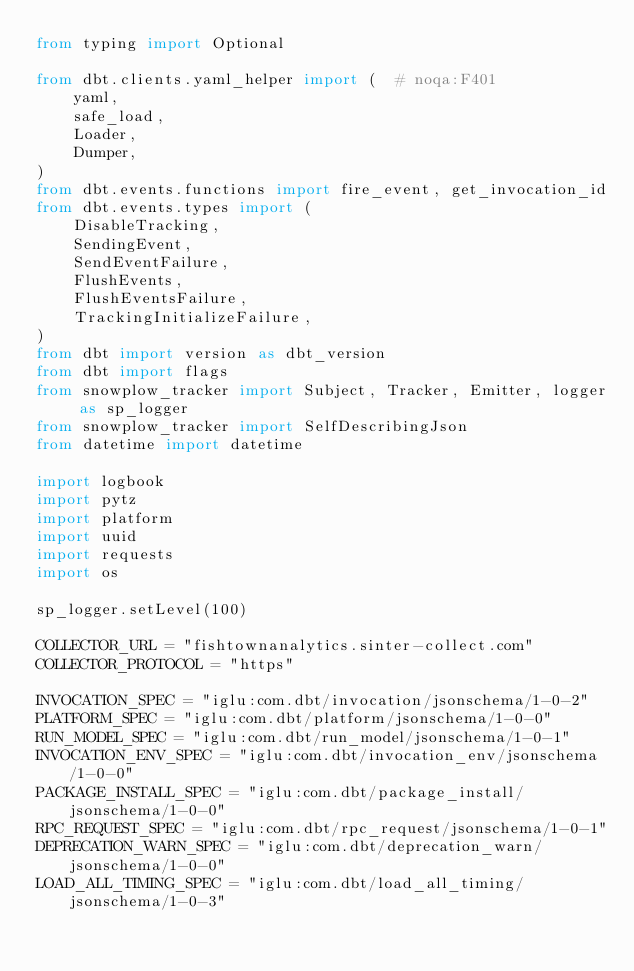<code> <loc_0><loc_0><loc_500><loc_500><_Python_>from typing import Optional

from dbt.clients.yaml_helper import (  # noqa:F401
    yaml,
    safe_load,
    Loader,
    Dumper,
)
from dbt.events.functions import fire_event, get_invocation_id
from dbt.events.types import (
    DisableTracking,
    SendingEvent,
    SendEventFailure,
    FlushEvents,
    FlushEventsFailure,
    TrackingInitializeFailure,
)
from dbt import version as dbt_version
from dbt import flags
from snowplow_tracker import Subject, Tracker, Emitter, logger as sp_logger
from snowplow_tracker import SelfDescribingJson
from datetime import datetime

import logbook
import pytz
import platform
import uuid
import requests
import os

sp_logger.setLevel(100)

COLLECTOR_URL = "fishtownanalytics.sinter-collect.com"
COLLECTOR_PROTOCOL = "https"

INVOCATION_SPEC = "iglu:com.dbt/invocation/jsonschema/1-0-2"
PLATFORM_SPEC = "iglu:com.dbt/platform/jsonschema/1-0-0"
RUN_MODEL_SPEC = "iglu:com.dbt/run_model/jsonschema/1-0-1"
INVOCATION_ENV_SPEC = "iglu:com.dbt/invocation_env/jsonschema/1-0-0"
PACKAGE_INSTALL_SPEC = "iglu:com.dbt/package_install/jsonschema/1-0-0"
RPC_REQUEST_SPEC = "iglu:com.dbt/rpc_request/jsonschema/1-0-1"
DEPRECATION_WARN_SPEC = "iglu:com.dbt/deprecation_warn/jsonschema/1-0-0"
LOAD_ALL_TIMING_SPEC = "iglu:com.dbt/load_all_timing/jsonschema/1-0-3"</code> 